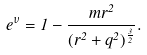Convert formula to latex. <formula><loc_0><loc_0><loc_500><loc_500>e ^ { \nu } = 1 - \frac { m r ^ { 2 } } { ( r ^ { 2 } + q ^ { 2 } ) ^ { \frac { 3 } { 2 } } } .</formula> 